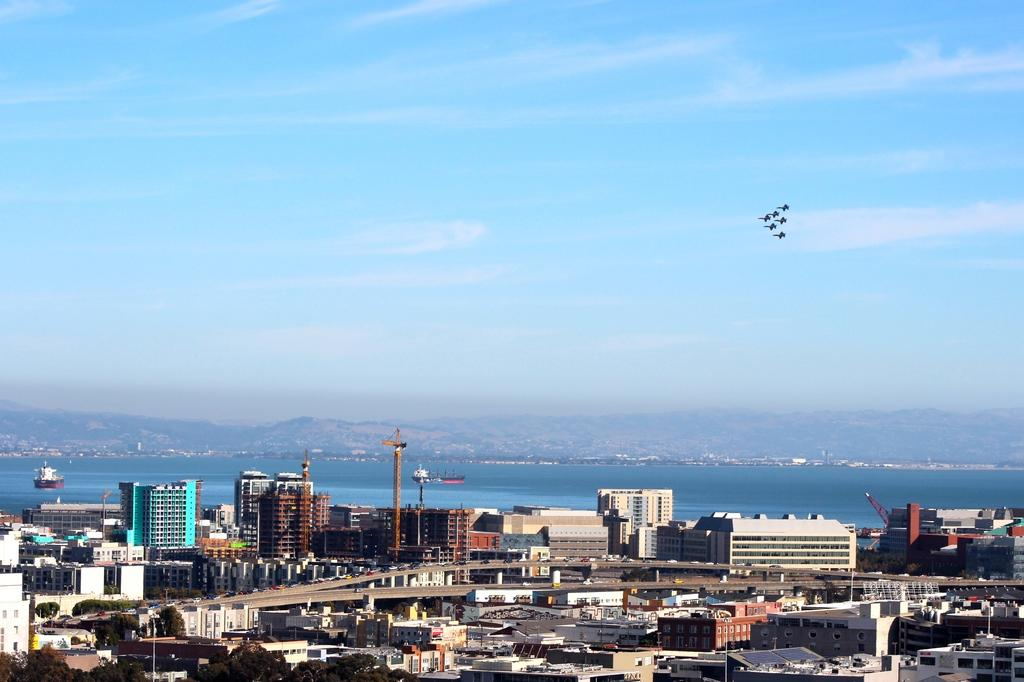What type of structures can be seen in the image? There are buildings in the image. What natural features are present in the image? There are hills in the image. What body of water is visible in the image? There is water visible in the image. What is flying in the sky in the image? There is something flying in the sky, but we cannot determine its exact nature from the provided facts. How many bulbs are hanging from the buildings in the image? There is no mention of bulbs in the provided facts, so we cannot determine their presence or quantity in the image. What type of yarn is being used by the army in the image? There is no mention of an army or yarn in the provided facts, so we cannot determine their presence or use in the image. 